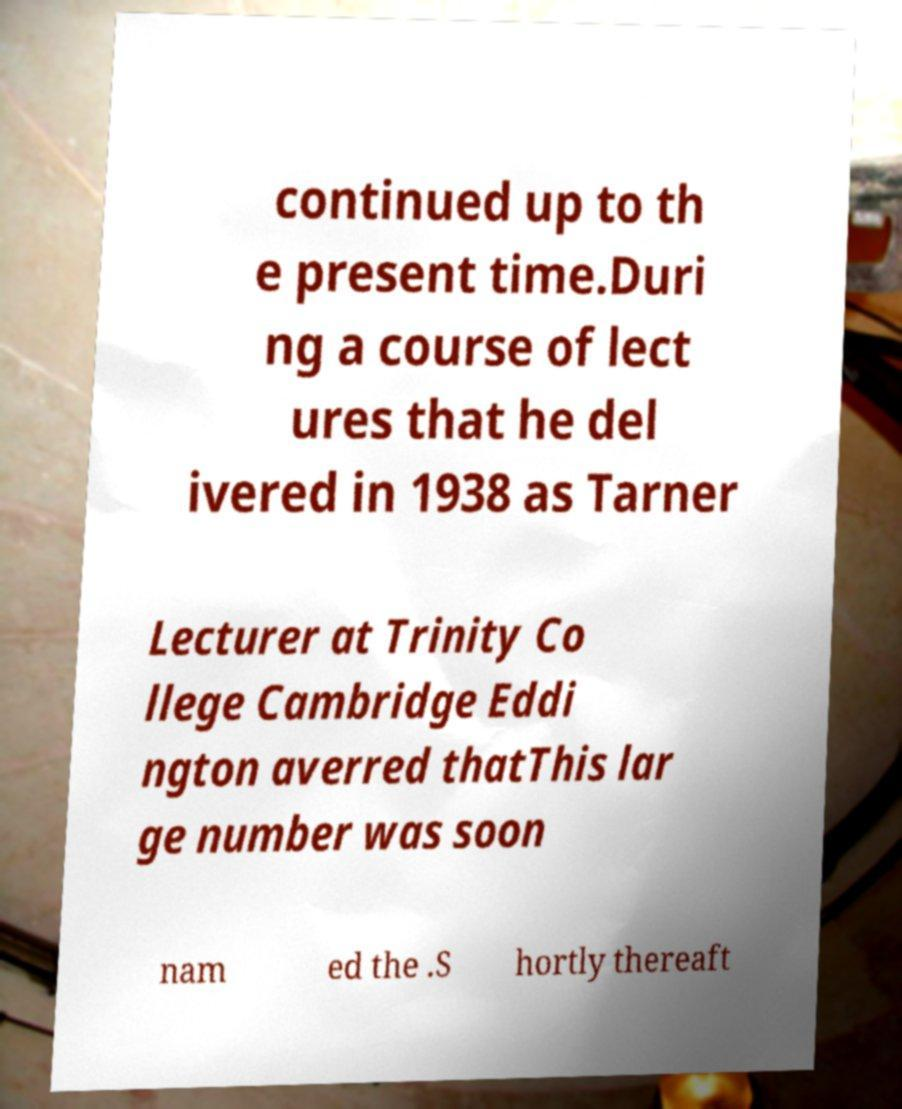Can you read and provide the text displayed in the image?This photo seems to have some interesting text. Can you extract and type it out for me? continued up to th e present time.Duri ng a course of lect ures that he del ivered in 1938 as Tarner Lecturer at Trinity Co llege Cambridge Eddi ngton averred thatThis lar ge number was soon nam ed the .S hortly thereaft 